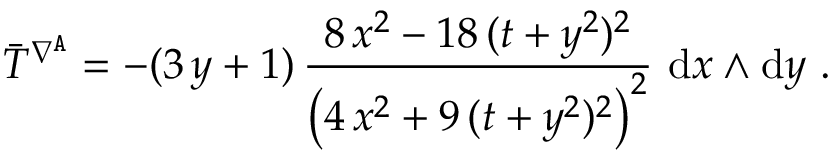Convert formula to latex. <formula><loc_0><loc_0><loc_500><loc_500>\bar { T } ^ { \nabla ^ { A } } = - ( 3 \, y + 1 ) \, \frac { 8 \, x ^ { 2 } - 1 8 \, ( t + y ^ { 2 } ) ^ { 2 } } { \left ( 4 \, x ^ { 2 } + 9 \, ( t + y ^ { 2 } ) ^ { 2 } \right ) ^ { 2 } } \ d x \wedge d y \ .</formula> 